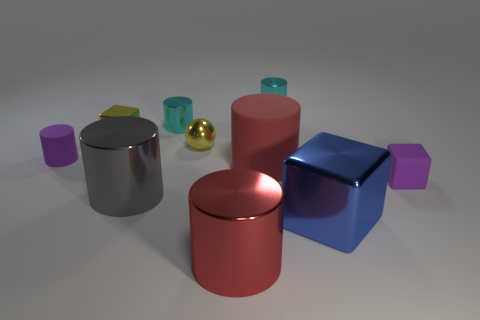Subtract 3 cylinders. How many cylinders are left? 3 Subtract all red cylinders. How many cylinders are left? 4 Subtract all cyan shiny cylinders. How many cylinders are left? 4 Subtract all blue cylinders. Subtract all blue cubes. How many cylinders are left? 6 Subtract all cylinders. How many objects are left? 4 Add 7 big shiny objects. How many big shiny objects are left? 10 Add 6 tiny cyan objects. How many tiny cyan objects exist? 8 Subtract 0 red balls. How many objects are left? 10 Subtract all blue objects. Subtract all big objects. How many objects are left? 5 